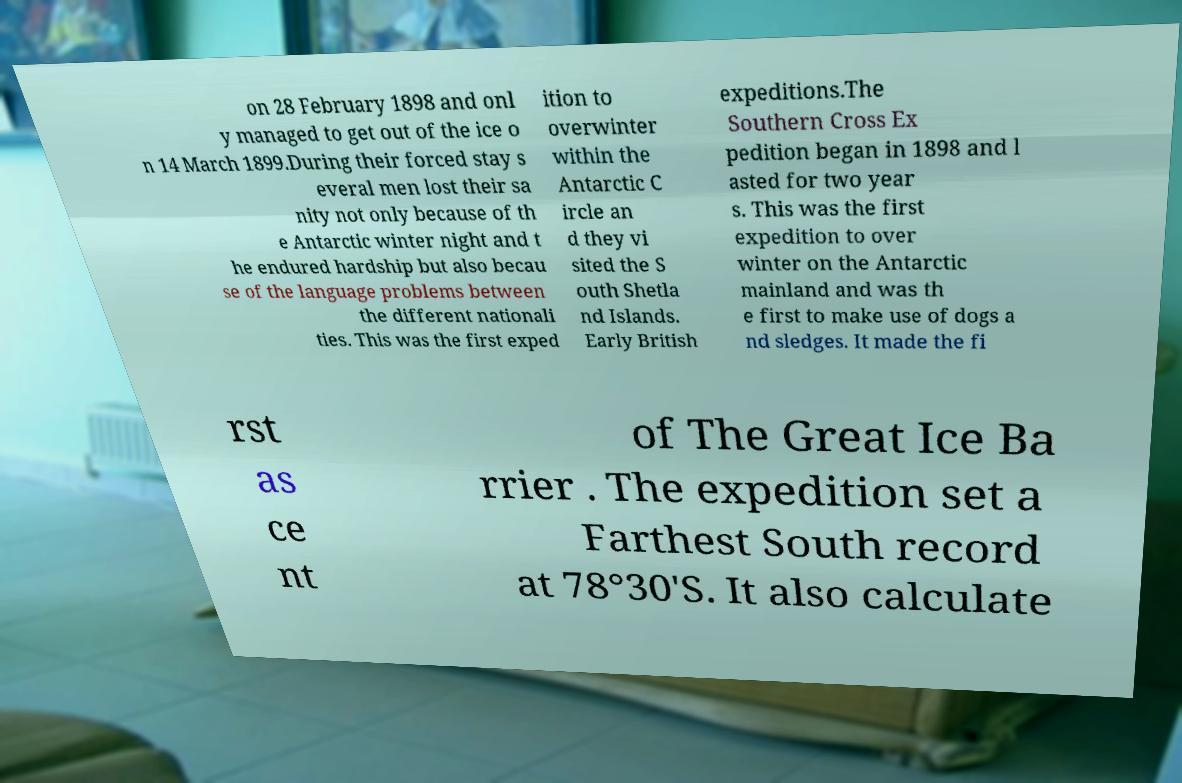Can you read and provide the text displayed in the image?This photo seems to have some interesting text. Can you extract and type it out for me? on 28 February 1898 and onl y managed to get out of the ice o n 14 March 1899.During their forced stay s everal men lost their sa nity not only because of th e Antarctic winter night and t he endured hardship but also becau se of the language problems between the different nationali ties. This was the first exped ition to overwinter within the Antarctic C ircle an d they vi sited the S outh Shetla nd Islands. Early British expeditions.The Southern Cross Ex pedition began in 1898 and l asted for two year s. This was the first expedition to over winter on the Antarctic mainland and was th e first to make use of dogs a nd sledges. It made the fi rst as ce nt of The Great Ice Ba rrier . The expedition set a Farthest South record at 78°30'S. It also calculate 